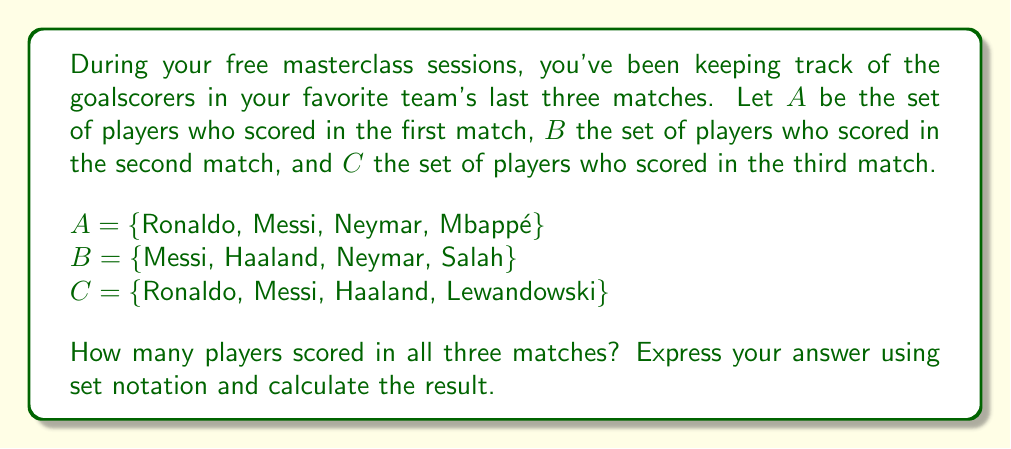Can you answer this question? To solve this problem, we need to find the intersection of all three sets. The intersection of sets represents the elements that are common to all the sets. In this case, we're looking for players who scored in all three matches.

Let's approach this step-by-step:

1) First, we need to express the intersection of all three sets using set notation:
   $A \cap B \cap C$

2) Now, let's find the players that are in all three sets:
   - Ronaldo is in A and C, but not in B
   - Messi is in A, B, and C
   - Neymar is in A and B, but not in C
   - Mbappé is only in A
   - Haaland is in B and C, but not in A
   - Salah is only in B
   - Lewandowski is only in C

3) From this analysis, we can see that Messi is the only player who appears in all three sets.

4) Therefore, $A \cap B \cap C = \{Messi\}$

5) To find how many players scored in all three matches, we need to calculate the cardinality (number of elements) of this set:
   $|A \cap B \cap C| = |\{Messi\}| = 1$

Thus, only 1 player scored in all three matches.
Answer: $|A \cap B \cap C| = 1$ 